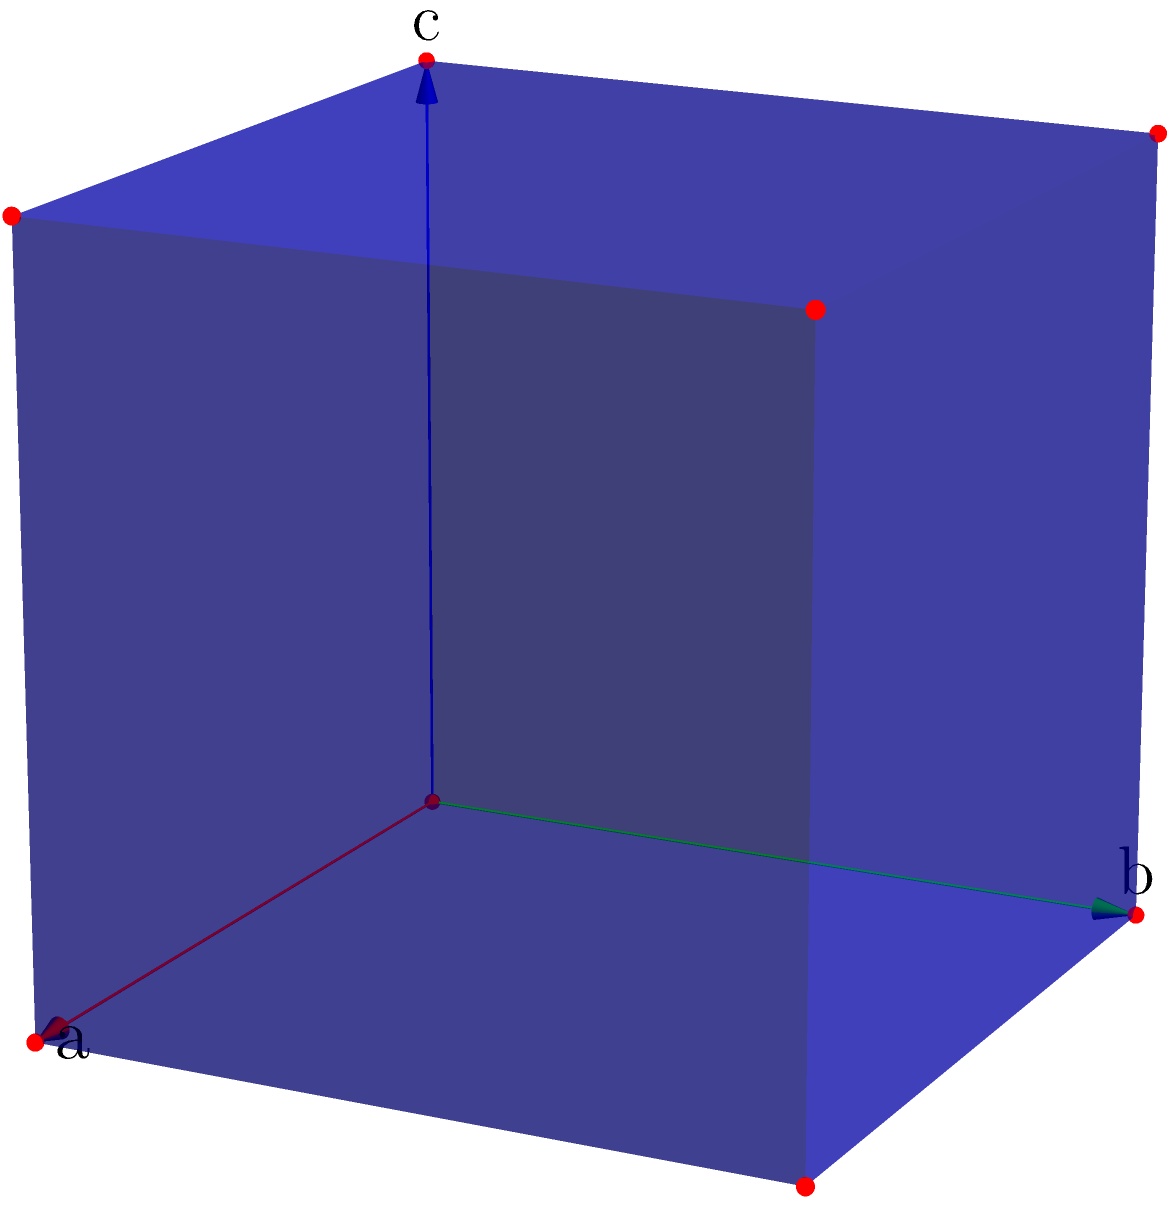Given a cubic unit cell with lattice parameters a = b = c = 4.08 Å and α = β = γ = 90°, calculate the volume of the unit cell in cubic angstroms (Å³). How many atoms are present in this unit cell if it represents a body-centered cubic (BCC) structure? To solve this problem, we'll follow these steps:

1. Calculate the volume of the unit cell:
   For a cubic unit cell, the volume is given by $V = a^3$, where $a$ is the length of one side.
   $V = (4.08 \text{ Å})^3 = 67.9277 \text{ Å}^3$

2. Determine the number of atoms in a BCC structure:
   A BCC structure has:
   - 1 atom at the center of the cube
   - 8 atoms at the corners, each shared by 8 adjacent unit cells (so $\frac{1}{8}$ of each corner atom belongs to this cell)

   Total number of atoms = $1 + (8 \times \frac{1}{8}) = 1 + 1 = 2$ atoms

Therefore, the volume of the unit cell is 67.9277 Å³ (rounded to four decimal places), and there are 2 atoms in the BCC unit cell.
Answer: 67.9277 Å³; 2 atoms 